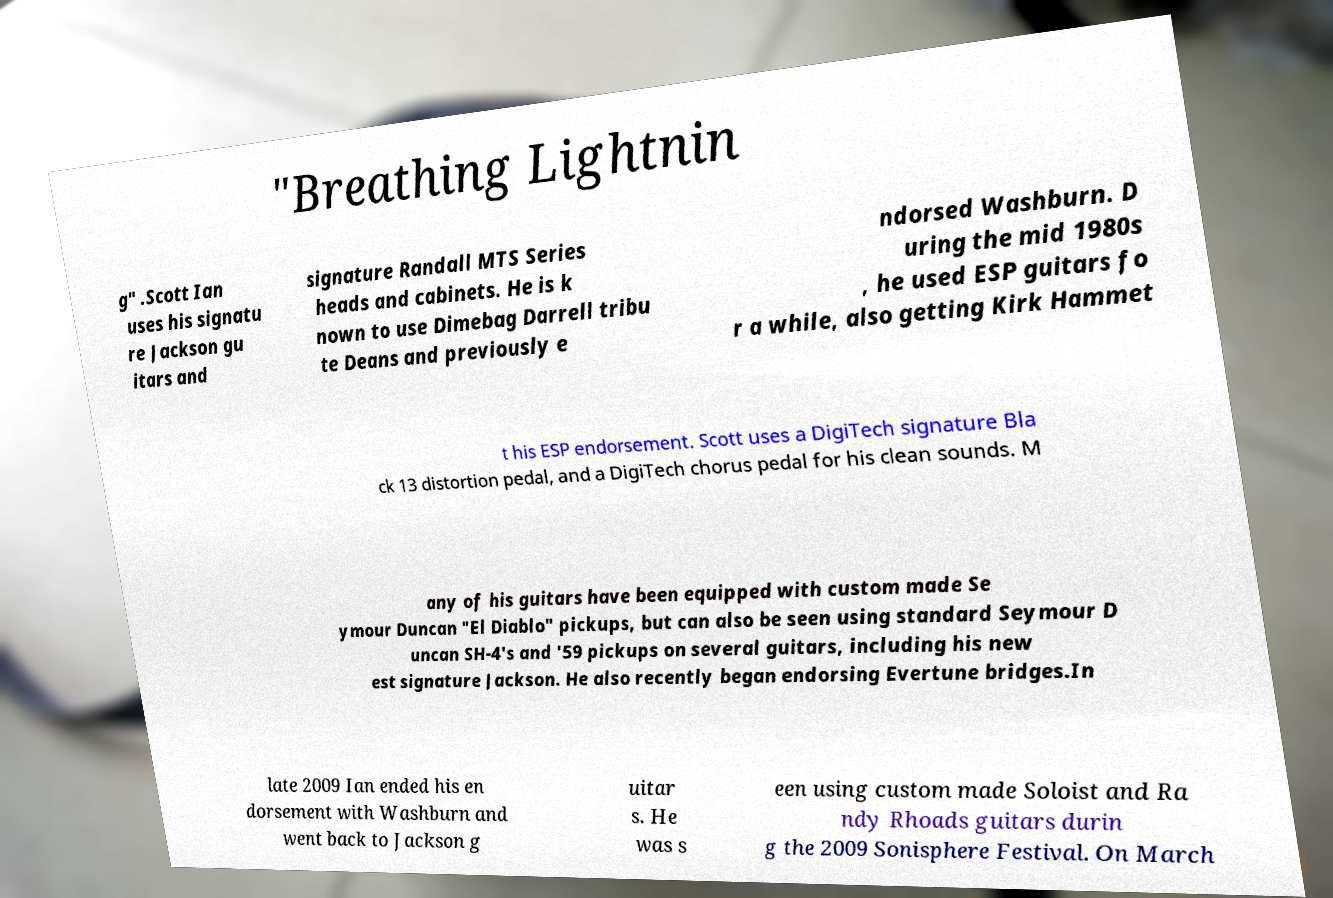Could you assist in decoding the text presented in this image and type it out clearly? "Breathing Lightnin g" .Scott Ian uses his signatu re Jackson gu itars and signature Randall MTS Series heads and cabinets. He is k nown to use Dimebag Darrell tribu te Deans and previously e ndorsed Washburn. D uring the mid 1980s , he used ESP guitars fo r a while, also getting Kirk Hammet t his ESP endorsement. Scott uses a DigiTech signature Bla ck 13 distortion pedal, and a DigiTech chorus pedal for his clean sounds. M any of his guitars have been equipped with custom made Se ymour Duncan "El Diablo" pickups, but can also be seen using standard Seymour D uncan SH-4's and '59 pickups on several guitars, including his new est signature Jackson. He also recently began endorsing Evertune bridges.In late 2009 Ian ended his en dorsement with Washburn and went back to Jackson g uitar s. He was s een using custom made Soloist and Ra ndy Rhoads guitars durin g the 2009 Sonisphere Festival. On March 